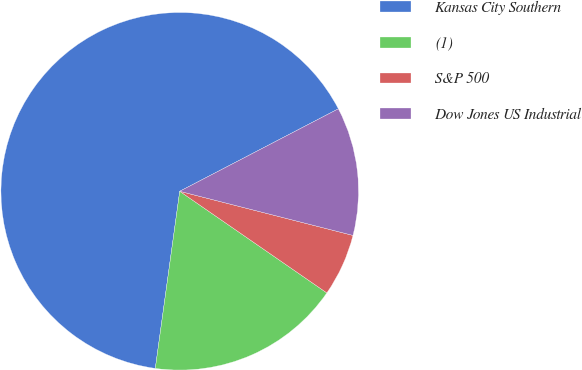Convert chart. <chart><loc_0><loc_0><loc_500><loc_500><pie_chart><fcel>Kansas City Southern<fcel>(1)<fcel>S&P 500<fcel>Dow Jones US Industrial<nl><fcel>65.19%<fcel>17.56%<fcel>5.65%<fcel>11.6%<nl></chart> 